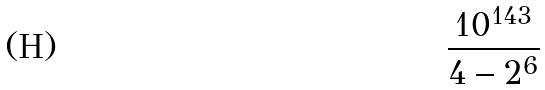Convert formula to latex. <formula><loc_0><loc_0><loc_500><loc_500>\frac { 1 0 ^ { 1 4 3 } } { 4 - 2 ^ { 6 } }</formula> 